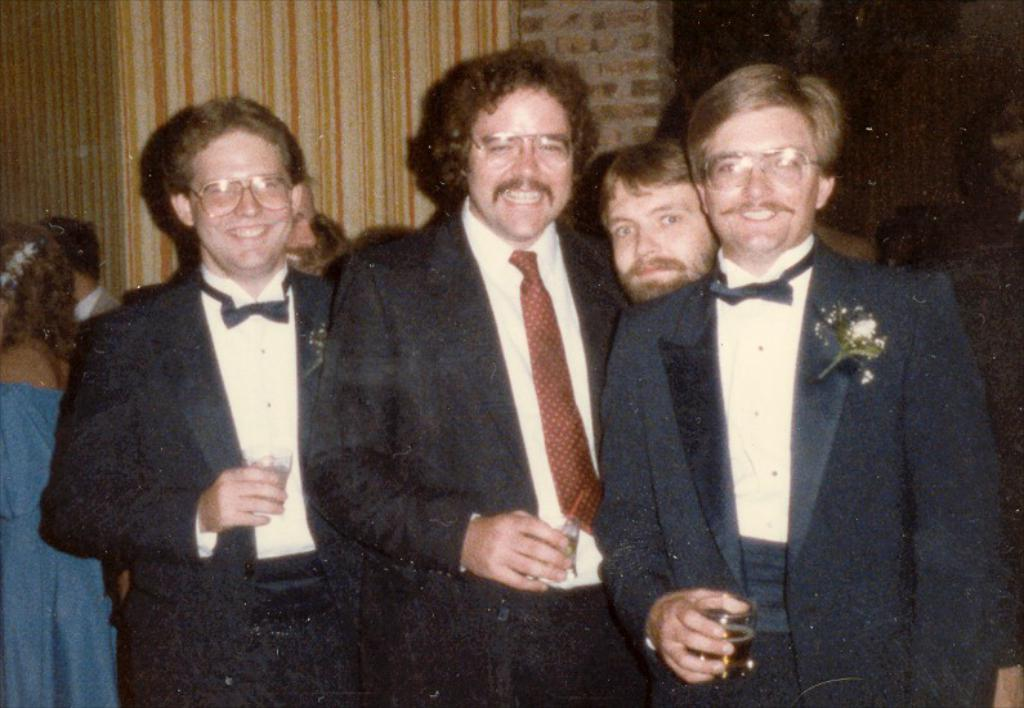What can be inferred about the age of the image? The image appears to be an old picture. How are the people in the image positioned? The people are standing in the image. What are the people holding in their hands? The people are holding glasses in the image. What is visible behind the people? There is a wall behind the people in the image. What type of toothbrush can be seen in the image? There is no toothbrush present in the image. How does the regret of the people in the image manifest? There is no indication of regret in the image; the people are holding glasses and standing. 